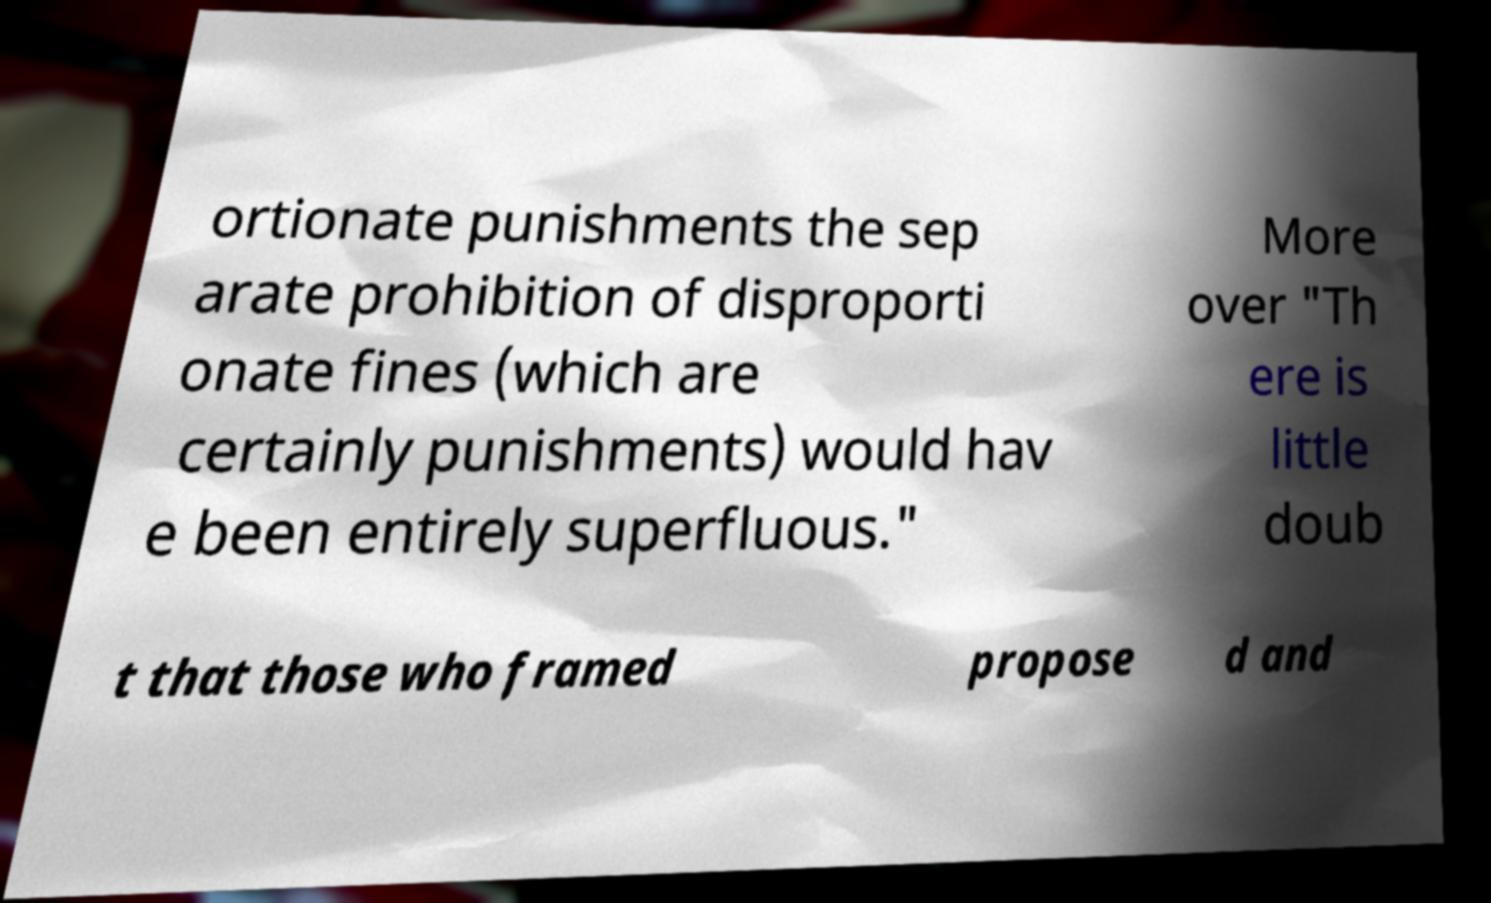Please identify and transcribe the text found in this image. ortionate punishments the sep arate prohibition of disproporti onate fines (which are certainly punishments) would hav e been entirely superfluous." More over "Th ere is little doub t that those who framed propose d and 